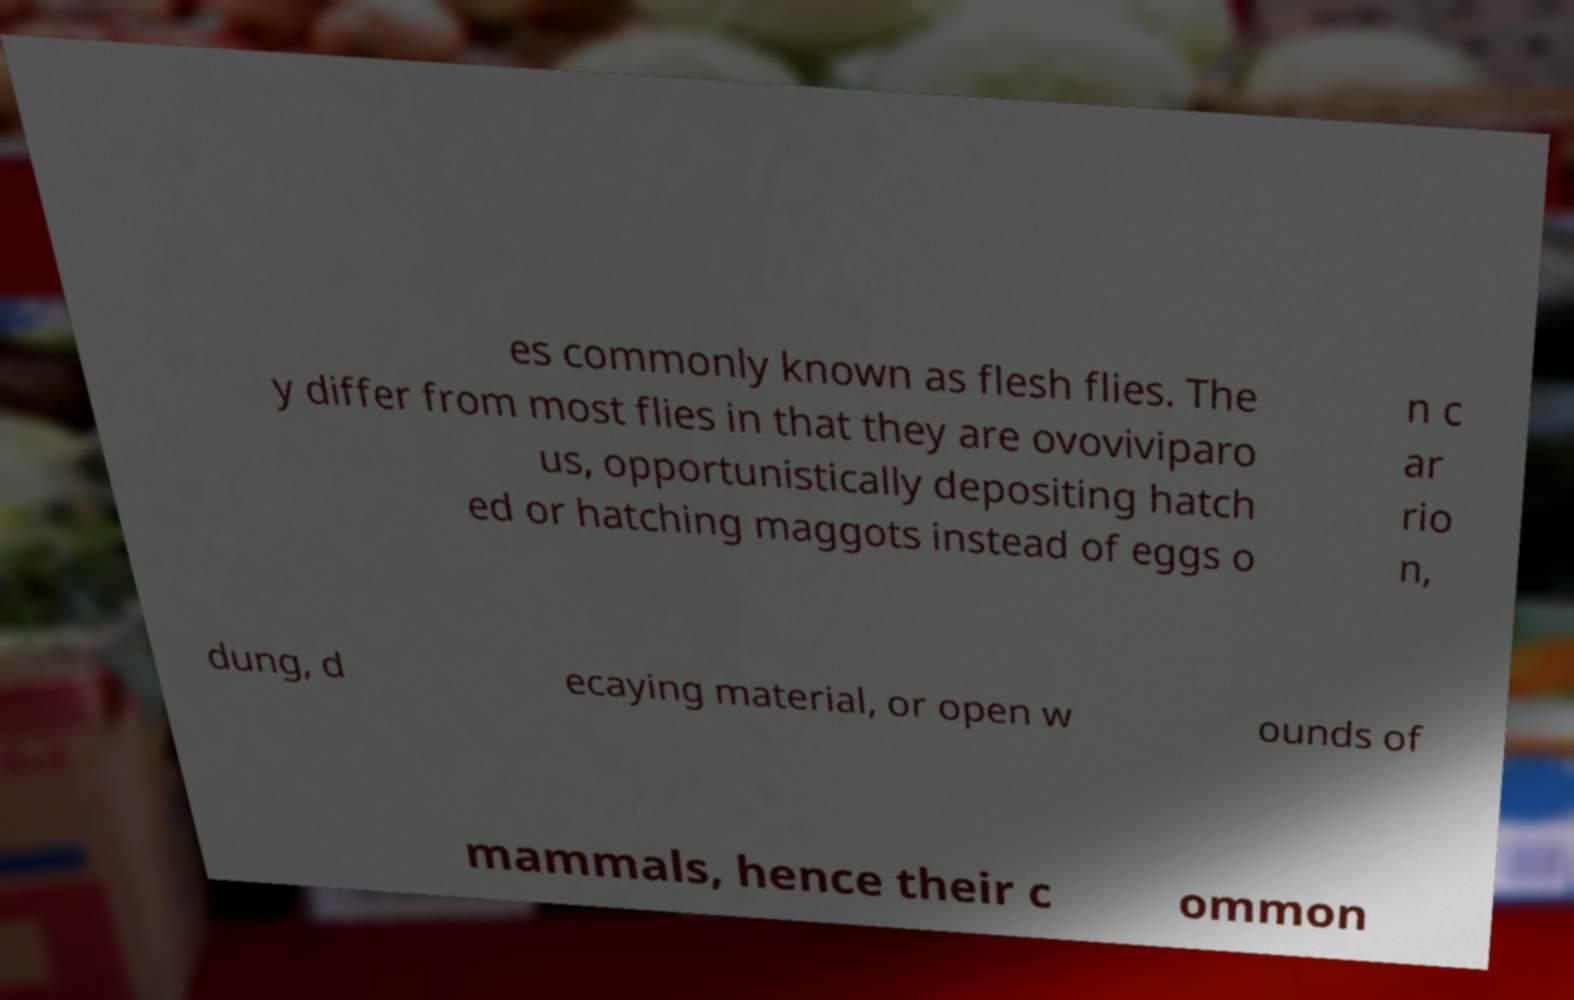Can you read and provide the text displayed in the image?This photo seems to have some interesting text. Can you extract and type it out for me? es commonly known as flesh flies. The y differ from most flies in that they are ovoviviparo us, opportunistically depositing hatch ed or hatching maggots instead of eggs o n c ar rio n, dung, d ecaying material, or open w ounds of mammals, hence their c ommon 